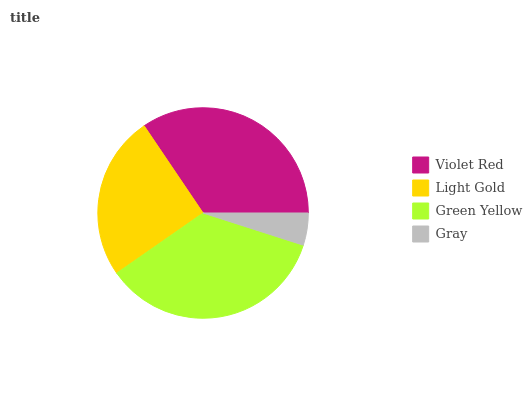Is Gray the minimum?
Answer yes or no. Yes. Is Green Yellow the maximum?
Answer yes or no. Yes. Is Light Gold the minimum?
Answer yes or no. No. Is Light Gold the maximum?
Answer yes or no. No. Is Violet Red greater than Light Gold?
Answer yes or no. Yes. Is Light Gold less than Violet Red?
Answer yes or no. Yes. Is Light Gold greater than Violet Red?
Answer yes or no. No. Is Violet Red less than Light Gold?
Answer yes or no. No. Is Violet Red the high median?
Answer yes or no. Yes. Is Light Gold the low median?
Answer yes or no. Yes. Is Green Yellow the high median?
Answer yes or no. No. Is Gray the low median?
Answer yes or no. No. 